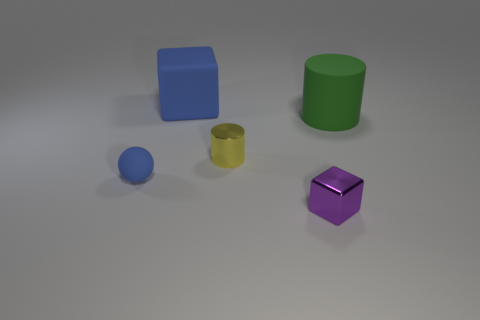What might be the function of these objects in the image? The objects do not seem to have a specific function; rather, they resemble simple geometric shapes often used for visual or educational purposes, like teaching about colors and shapes or for graphic design and 3D modeling practice. 